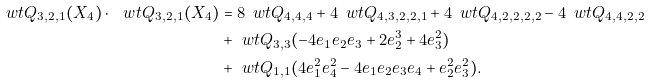Convert formula to latex. <formula><loc_0><loc_0><loc_500><loc_500>\ w t { Q } _ { 3 , 2 , 1 } ( X _ { 4 } ) \cdot \ w t { Q } _ { 3 , 2 , 1 } ( X _ { 4 } ) & = 8 \, \ w t { Q } _ { 4 , 4 , 4 } + 4 \, \ w t { Q } _ { 4 , 3 , 2 , 2 , 1 } + 4 \, \ w t { Q } _ { 4 , 2 , 2 , 2 , 2 } - 4 \, \ w t { Q } _ { 4 , 4 , 2 , 2 } \\ & + \ w t { Q } _ { 3 , 3 } ( - 4 e _ { 1 } e _ { 2 } e _ { 3 } + 2 e _ { 2 } ^ { 3 } + 4 e _ { 3 } ^ { 2 } ) \\ & + \ w t { Q } _ { 1 , 1 } ( 4 e _ { 1 } ^ { 2 } e _ { 4 } ^ { 2 } - 4 e _ { 1 } e _ { 2 } e _ { 3 } e _ { 4 } + e _ { 2 } ^ { 2 } e _ { 3 } ^ { 2 } ) .</formula> 